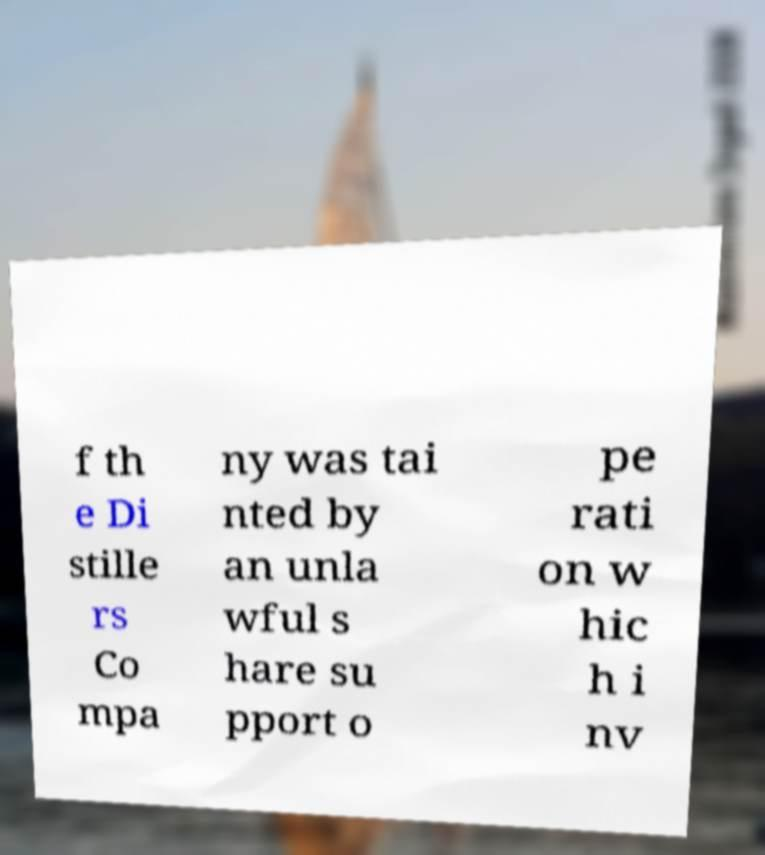Can you read and provide the text displayed in the image?This photo seems to have some interesting text. Can you extract and type it out for me? f th e Di stille rs Co mpa ny was tai nted by an unla wful s hare su pport o pe rati on w hic h i nv 